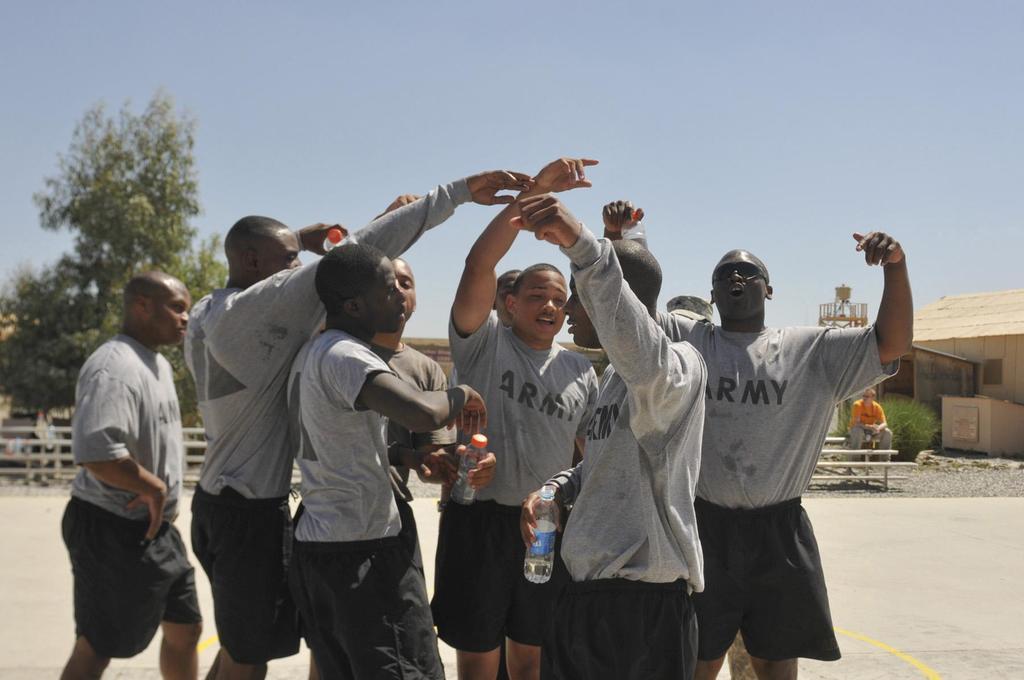Could you give a brief overview of what you see in this image? In this image I can see a group of people standing seems like they are dancing. I can see some of them are holding water bottles in their hands. I can see wooden fence, trees and a car behind them I can see a wooden house and a person sitting on a wooden bench on the right hand side. At the top of the image I can see the sky at the bottom of the image I can see the ground. 